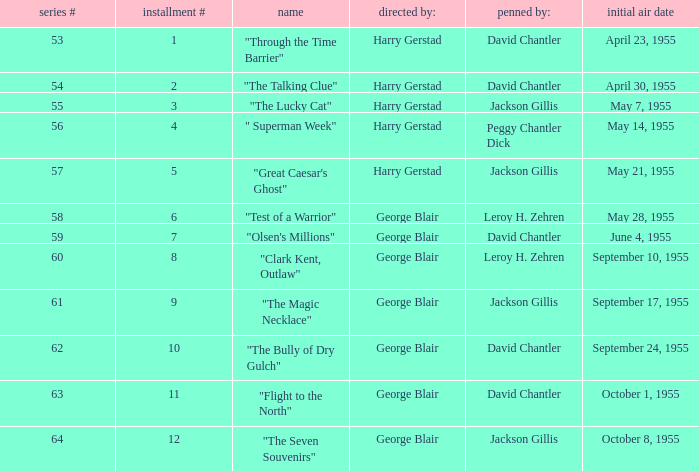Who was "The Magic Necklace" written by? Jackson Gillis. 